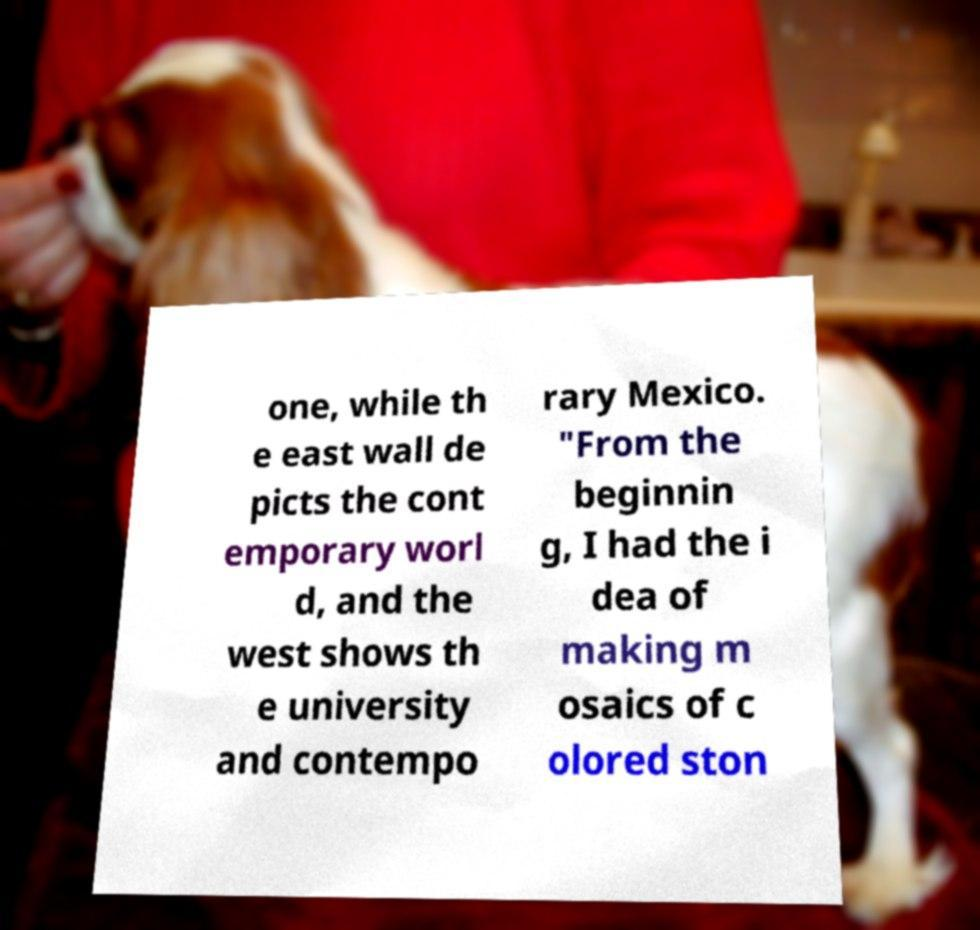Please identify and transcribe the text found in this image. one, while th e east wall de picts the cont emporary worl d, and the west shows th e university and contempo rary Mexico. "From the beginnin g, I had the i dea of making m osaics of c olored ston 